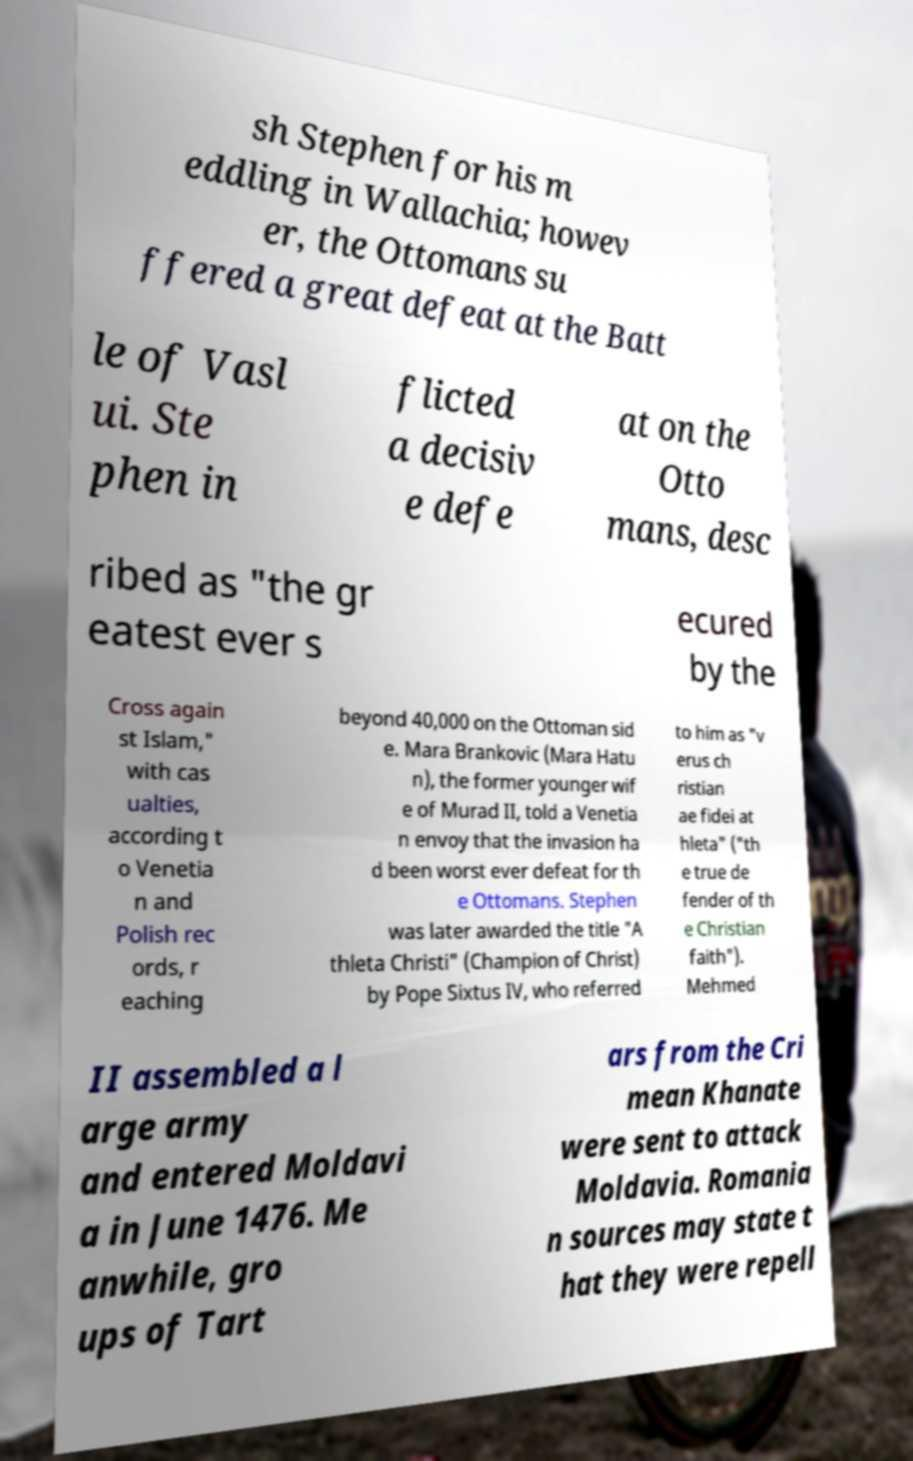Please identify and transcribe the text found in this image. sh Stephen for his m eddling in Wallachia; howev er, the Ottomans su ffered a great defeat at the Batt le of Vasl ui. Ste phen in flicted a decisiv e defe at on the Otto mans, desc ribed as "the gr eatest ever s ecured by the Cross again st Islam," with cas ualties, according t o Venetia n and Polish rec ords, r eaching beyond 40,000 on the Ottoman sid e. Mara Brankovic (Mara Hatu n), the former younger wif e of Murad II, told a Venetia n envoy that the invasion ha d been worst ever defeat for th e Ottomans. Stephen was later awarded the title "A thleta Christi" (Champion of Christ) by Pope Sixtus IV, who referred to him as "v erus ch ristian ae fidei at hleta" ("th e true de fender of th e Christian faith"). Mehmed II assembled a l arge army and entered Moldavi a in June 1476. Me anwhile, gro ups of Tart ars from the Cri mean Khanate were sent to attack Moldavia. Romania n sources may state t hat they were repell 